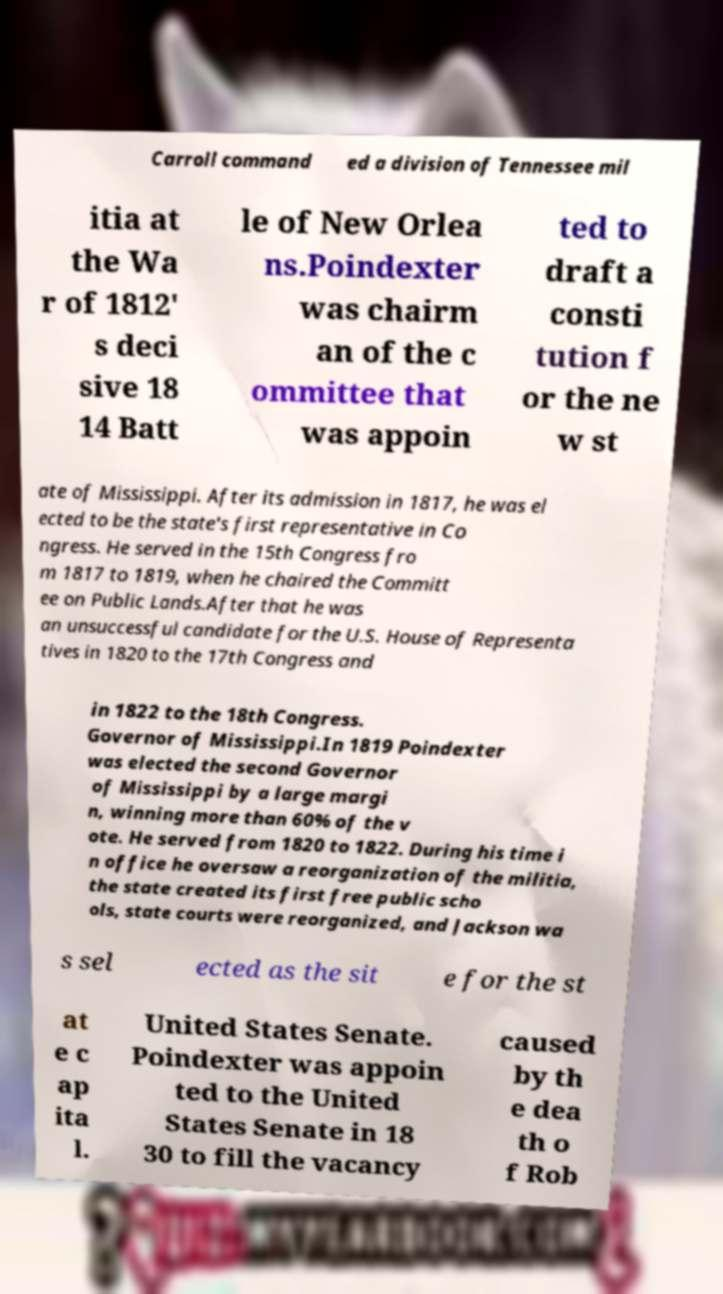Can you accurately transcribe the text from the provided image for me? Carroll command ed a division of Tennessee mil itia at the Wa r of 1812' s deci sive 18 14 Batt le of New Orlea ns.Poindexter was chairm an of the c ommittee that was appoin ted to draft a consti tution f or the ne w st ate of Mississippi. After its admission in 1817, he was el ected to be the state's first representative in Co ngress. He served in the 15th Congress fro m 1817 to 1819, when he chaired the Committ ee on Public Lands.After that he was an unsuccessful candidate for the U.S. House of Representa tives in 1820 to the 17th Congress and in 1822 to the 18th Congress. Governor of Mississippi.In 1819 Poindexter was elected the second Governor of Mississippi by a large margi n, winning more than 60% of the v ote. He served from 1820 to 1822. During his time i n office he oversaw a reorganization of the militia, the state created its first free public scho ols, state courts were reorganized, and Jackson wa s sel ected as the sit e for the st at e c ap ita l. United States Senate. Poindexter was appoin ted to the United States Senate in 18 30 to fill the vacancy caused by th e dea th o f Rob 